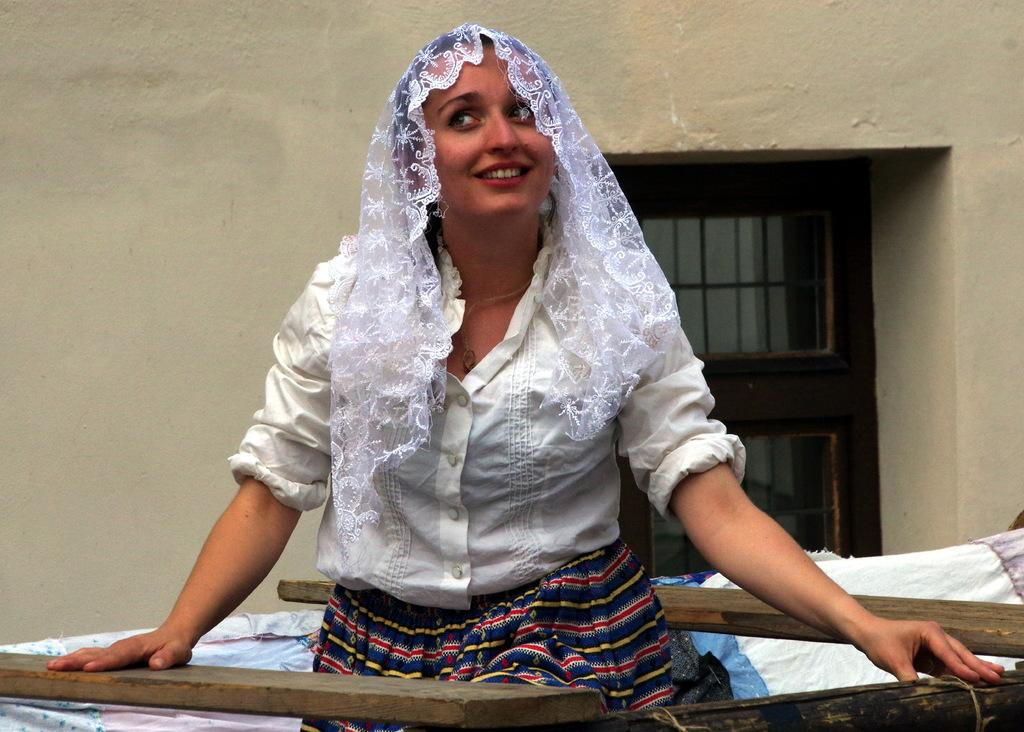Who is the main subject in the image? There is a woman in the center of the image. What is located at the bottom of the image? There are clothes and wooden sticks at the bottom of the image. What can be seen in the background of the image? There is a wall and a window in the background of the image. What type of toys can be seen on the wall in the image? There are no toys visible on the wall in the image. Is the image taken during the night or day? The image does not provide any information about the time of day, so it cannot be determined whether it is night or day. 